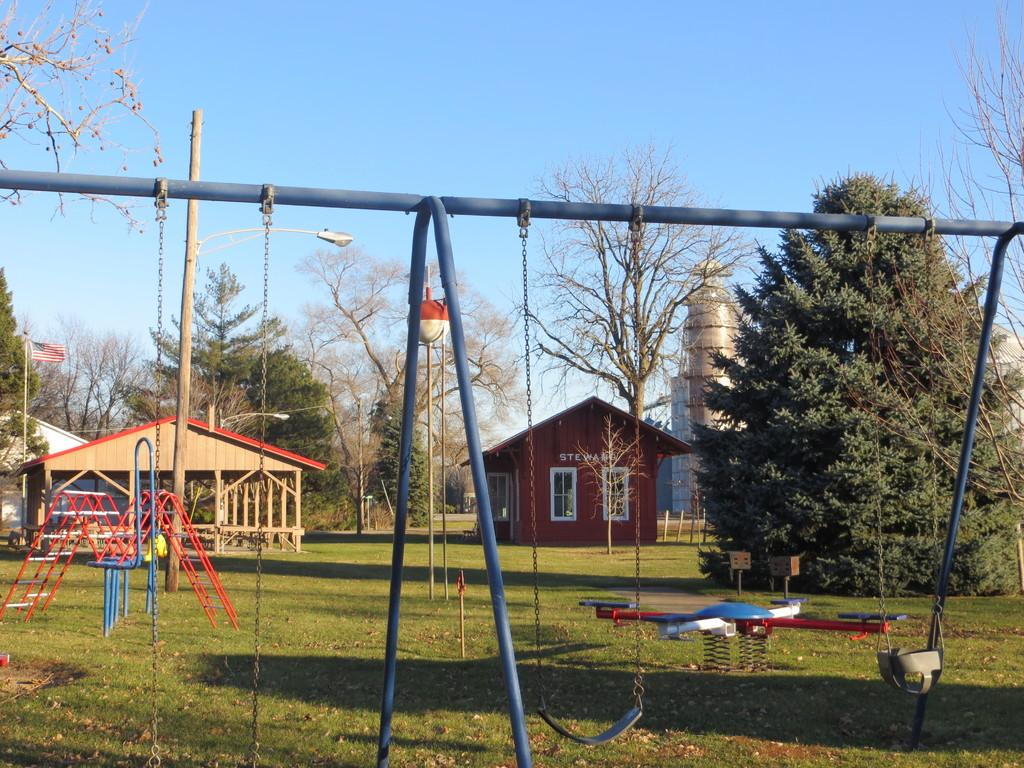What type of playground equipment can be seen in the image? There are swings in the image. What supports the swings in the image? There are poles in the image that support the swings. What connects the swings to the poles? There are chains in the image that connect the swings to the poles. What type of structures are present in the image? There are sheds and a building in the image. What can be seen in the sheds and building? The presence of windows in the sheds and building suggests that there may be rooms or spaces inside. What type of vegetation is visible in the image? There are trees in the image. What is the purpose of the flag in the image? The flag in the image may indicate a specific location or represent a group or organization. What type of ground surface is visible in the image? There is grass in the image. What else can be seen in the image? There are some objects in the image, but their specific purpose or function is not clear from the provided facts. What is visible in the background of the image? The sky is visible in the background of the image. What type of lipstick is being applied in the image? There is no lipstick or application of lipstick present in the image. Where is the lunchroom located in the image? There is no mention of a lunchroom in the image; it features swings, poles, chains, sheds, windows, trees, a flag, a building, grass, and some objects. 